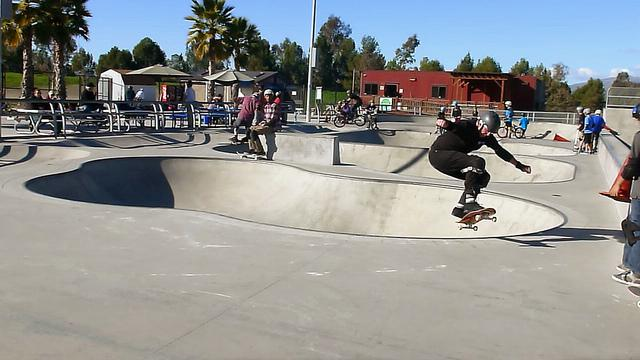Where are the skaters located? skate park 